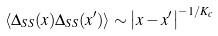<formula> <loc_0><loc_0><loc_500><loc_500>\langle \Delta _ { S S } ( x ) \Delta _ { S S } ( x ^ { \prime } ) \rangle \sim \left | x - x ^ { \prime } \right | ^ { - 1 / K _ { c } }</formula> 